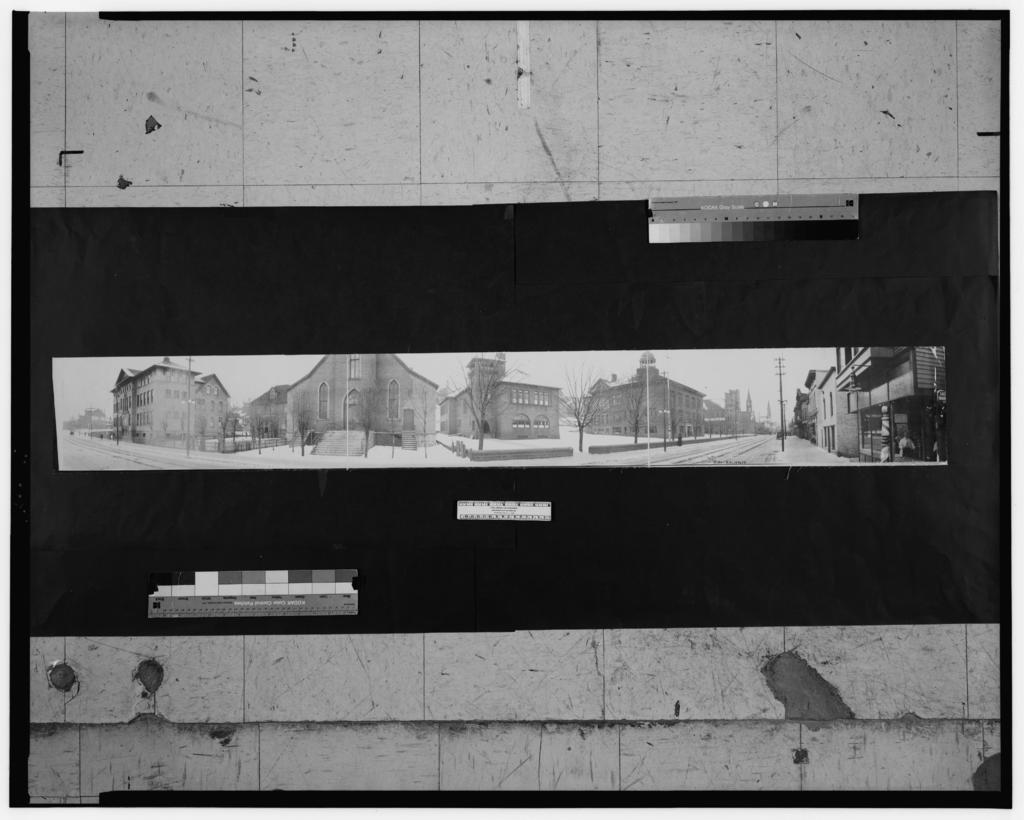Please provide a concise description of this image. This black and white image is an edited image. In the center there are buildings. In front of the buildings there are trees and roads. Above the buildings there is the sky. There are color shades icons in the image. 